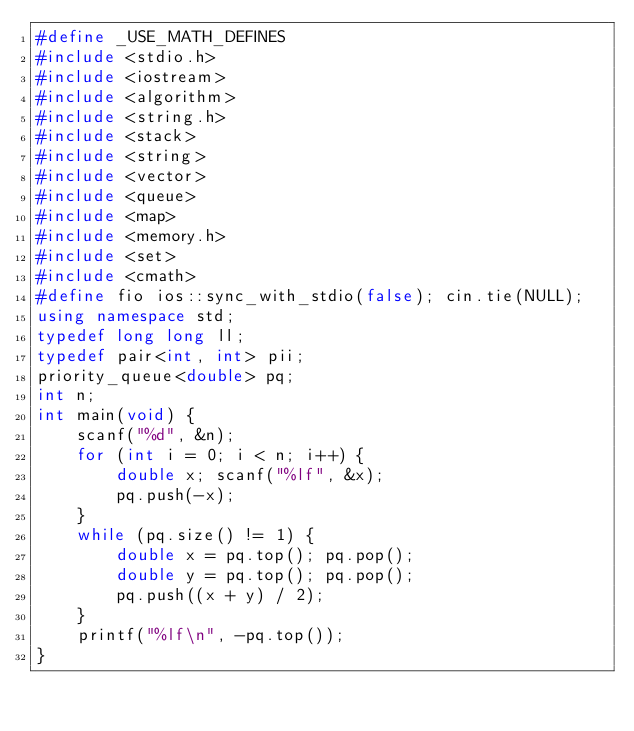Convert code to text. <code><loc_0><loc_0><loc_500><loc_500><_C++_>#define _USE_MATH_DEFINES
#include <stdio.h>
#include <iostream>
#include <algorithm>
#include <string.h>
#include <stack>
#include <string>
#include <vector>
#include <queue>
#include <map>
#include <memory.h>
#include <set>
#include <cmath>
#define fio ios::sync_with_stdio(false); cin.tie(NULL);
using namespace std;
typedef long long ll;
typedef pair<int, int> pii;
priority_queue<double> pq;
int n;
int main(void) {
	scanf("%d", &n);
	for (int i = 0; i < n; i++) {
		double x; scanf("%lf", &x);
		pq.push(-x);
	}
	while (pq.size() != 1) {
		double x = pq.top(); pq.pop();
		double y = pq.top(); pq.pop();
		pq.push((x + y) / 2);
	}
	printf("%lf\n", -pq.top());
}
</code> 